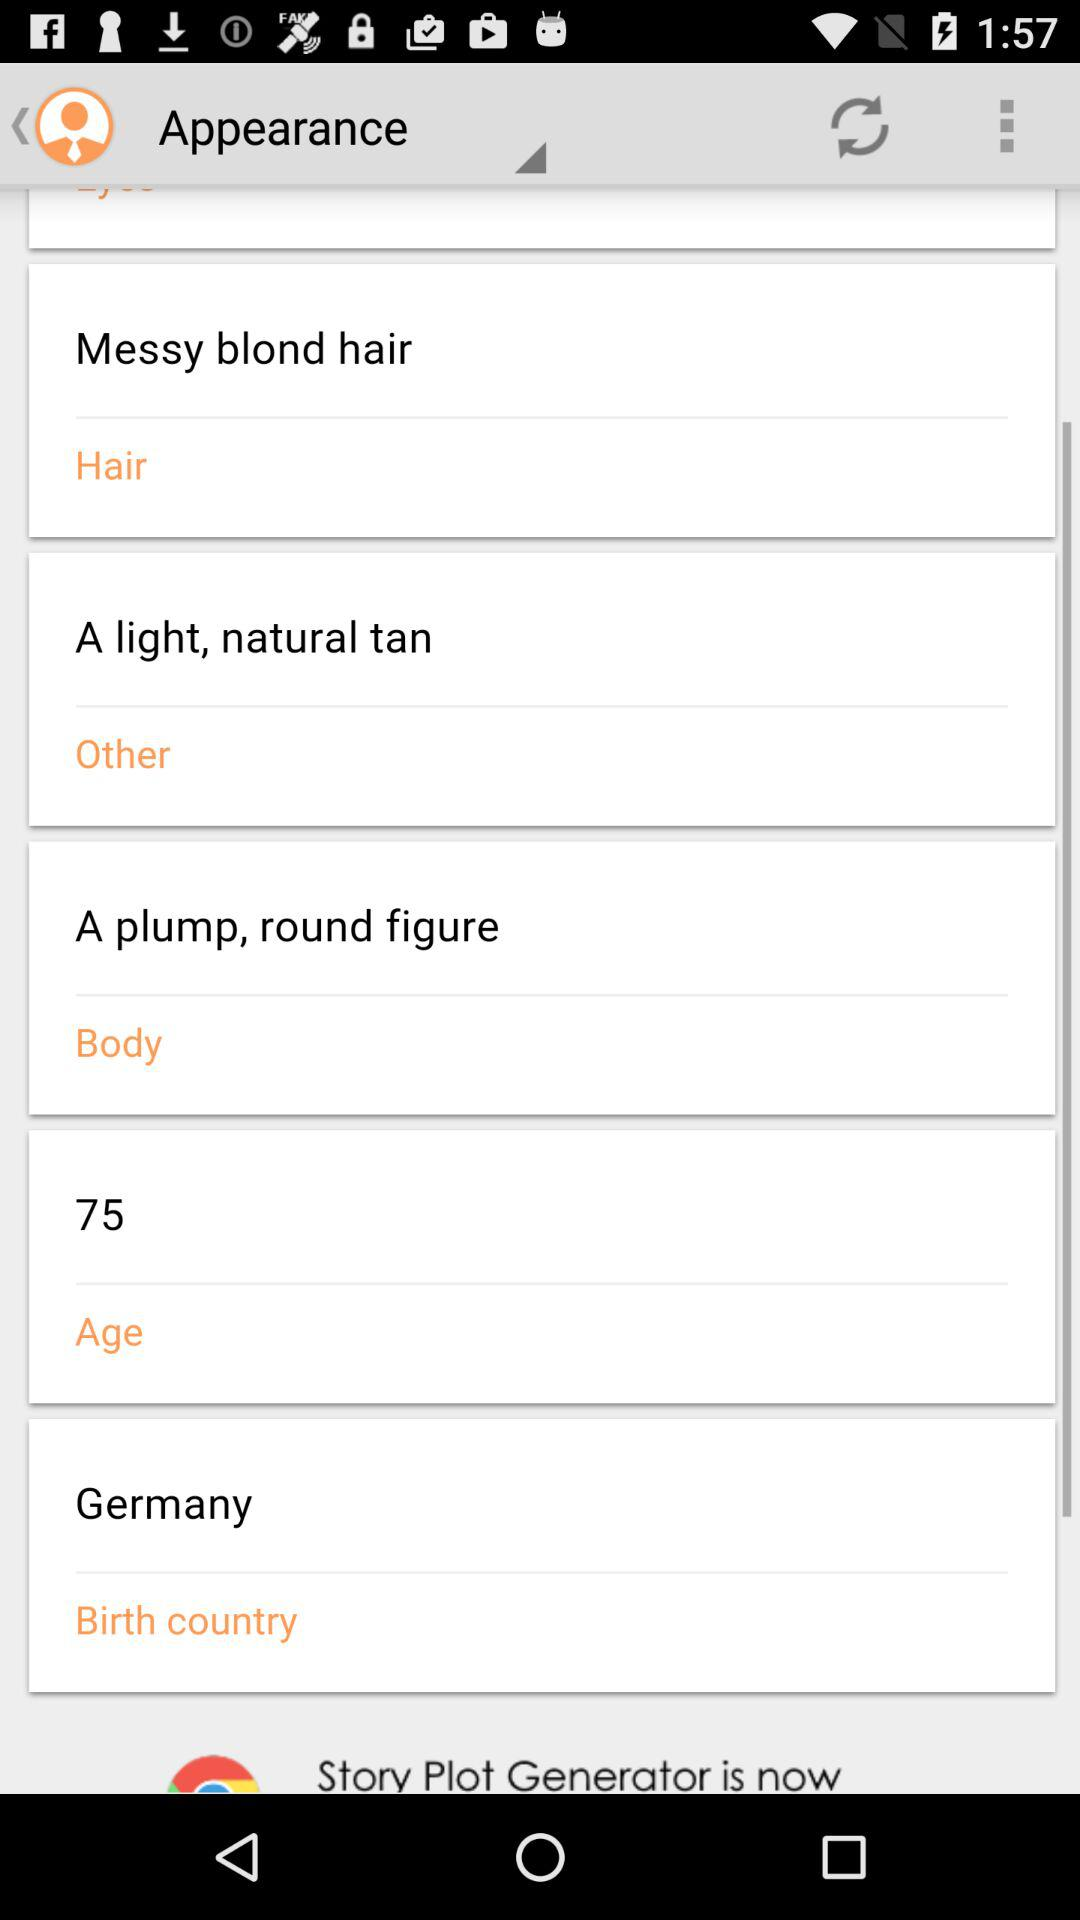What is the age? The age is 75 years. 